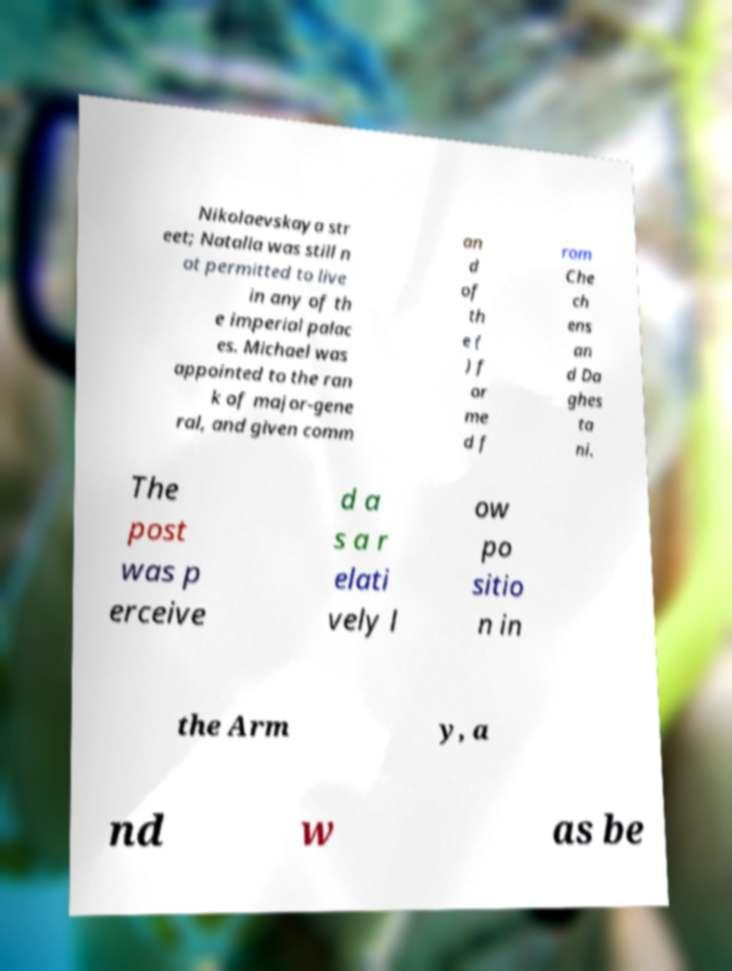Could you extract and type out the text from this image? Nikolaevskaya str eet; Natalia was still n ot permitted to live in any of th e imperial palac es. Michael was appointed to the ran k of major-gene ral, and given comm an d of th e ( ) f or me d f rom Che ch ens an d Da ghes ta ni. The post was p erceive d a s a r elati vely l ow po sitio n in the Arm y, a nd w as be 